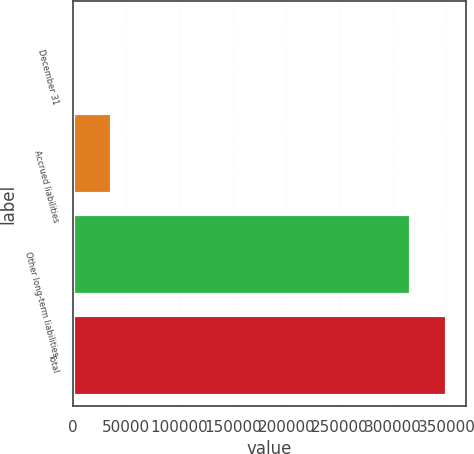Convert chart to OTSL. <chart><loc_0><loc_0><loc_500><loc_500><bar_chart><fcel>December 31<fcel>Accrued liabilities<fcel>Other long-term liabilities<fcel>Total<nl><fcel>2006<fcel>36320.1<fcel>316401<fcel>350715<nl></chart> 